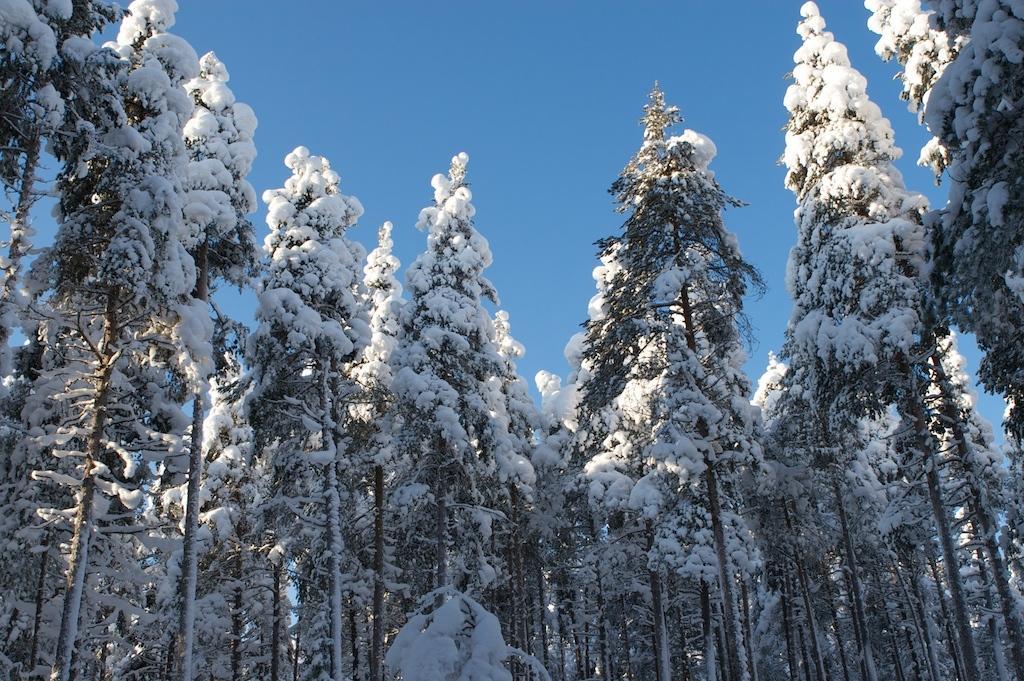What type of vegetation can be seen in the picture? There are trees in the picture. What is covering the trees in the image? There is snow on the trees. What is the condition of the sky in the picture? The sky is cloudy in the picture. What color is the balloon tied to the tree in the image? There is no balloon present in the image; it only features trees with snow and a cloudy sky. 